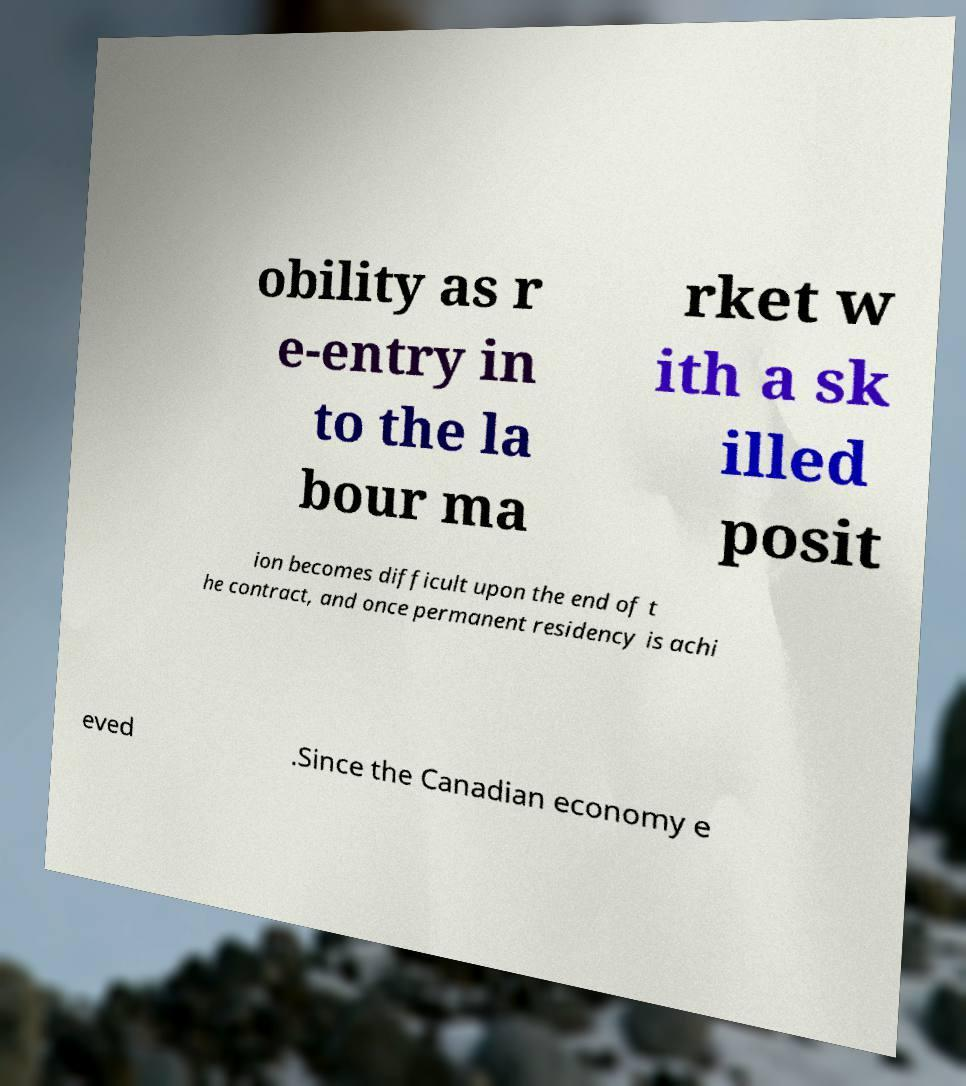What messages or text are displayed in this image? I need them in a readable, typed format. obility as r e-entry in to the la bour ma rket w ith a sk illed posit ion becomes difficult upon the end of t he contract, and once permanent residency is achi eved .Since the Canadian economy e 